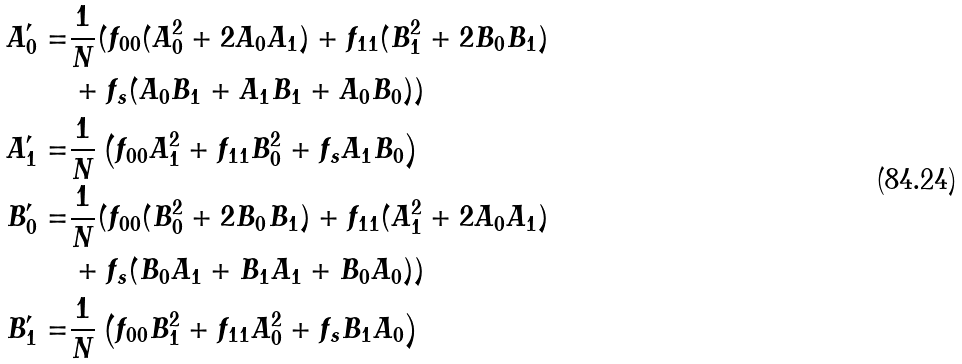Convert formula to latex. <formula><loc_0><loc_0><loc_500><loc_500>A _ { 0 } ^ { \prime } = & \frac { 1 } { N } ( f _ { 0 0 } ( A _ { 0 } ^ { 2 } + 2 A _ { 0 } A _ { 1 } ) + f _ { 1 1 } ( B _ { 1 } ^ { 2 } + 2 B _ { 0 } B _ { 1 } ) \\ & + f _ { s } ( A _ { 0 } B _ { 1 } + A _ { 1 } B _ { 1 } + A _ { 0 } B _ { 0 } ) ) \\ A _ { 1 } ^ { \prime } = & \frac { 1 } { N } \left ( f _ { 0 0 } A _ { 1 } ^ { 2 } + f _ { 1 1 } B _ { 0 } ^ { 2 } + f _ { s } A _ { 1 } B _ { 0 } \right ) \\ B _ { 0 } ^ { \prime } = & \frac { 1 } { N } ( f _ { 0 0 } ( B _ { 0 } ^ { 2 } + 2 B _ { 0 } B _ { 1 } ) + f _ { 1 1 } ( A _ { 1 } ^ { 2 } + 2 A _ { 0 } A _ { 1 } ) \\ & + f _ { s } ( B _ { 0 } A _ { 1 } + B _ { 1 } A _ { 1 } + B _ { 0 } A _ { 0 } ) ) \\ B _ { 1 } ^ { \prime } = & \frac { 1 } { N } \left ( f _ { 0 0 } B _ { 1 } ^ { 2 } + f _ { 1 1 } A _ { 0 } ^ { 2 } + f _ { s } B _ { 1 } A _ { 0 } \right )</formula> 